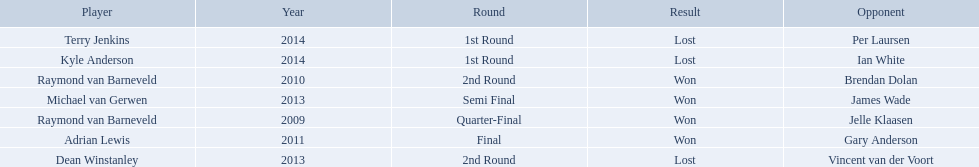Who were all the players? Raymond van Barneveld, Raymond van Barneveld, Adrian Lewis, Dean Winstanley, Michael van Gerwen, Terry Jenkins, Kyle Anderson. Which of these played in 2014? Terry Jenkins, Kyle Anderson. Who were their opponents? Per Laursen, Ian White. Which of these beat terry jenkins? Per Laursen. 